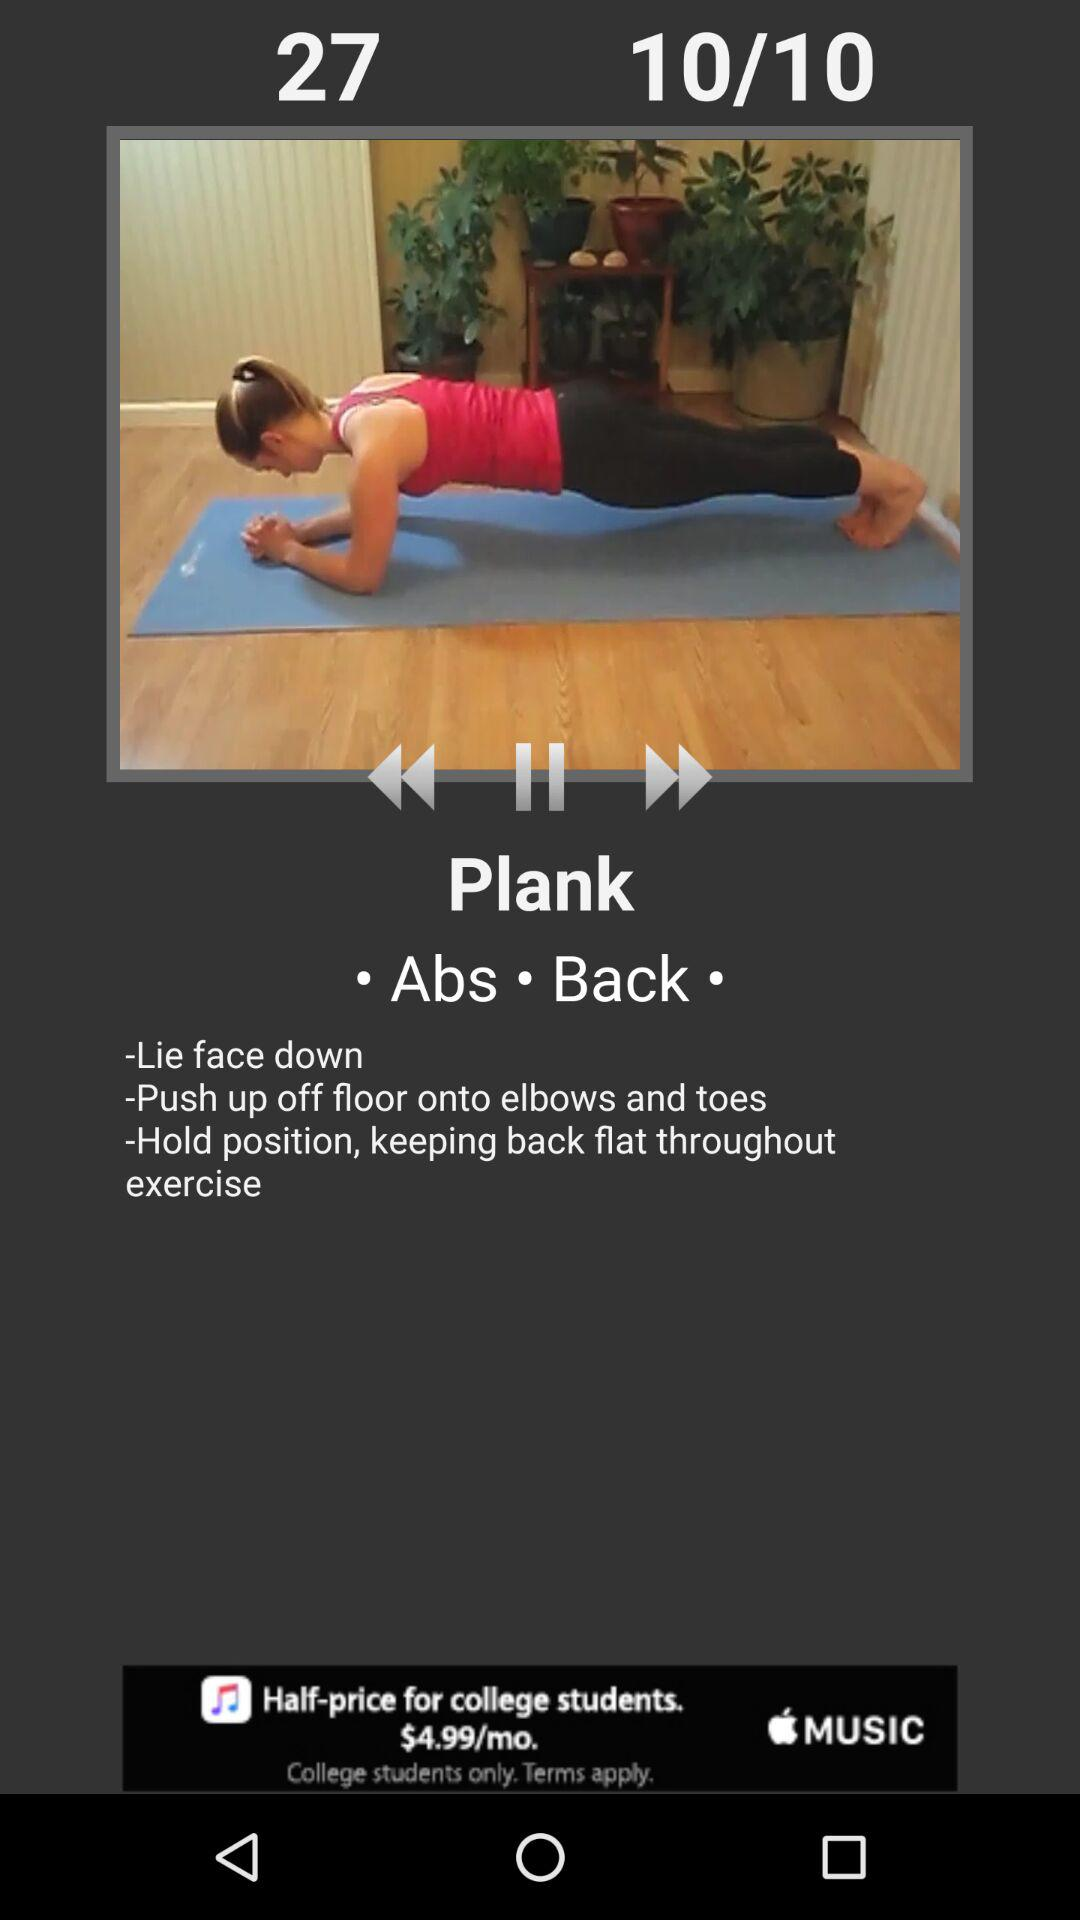Which exercise is going on? The exercise that is going on is "Plank". 